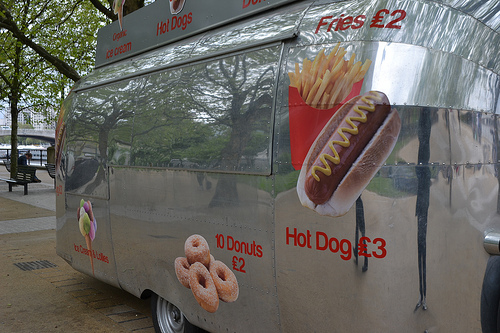<image>
Is there a hotdog in front of the fries? Yes. The hotdog is positioned in front of the fries, appearing closer to the camera viewpoint. 